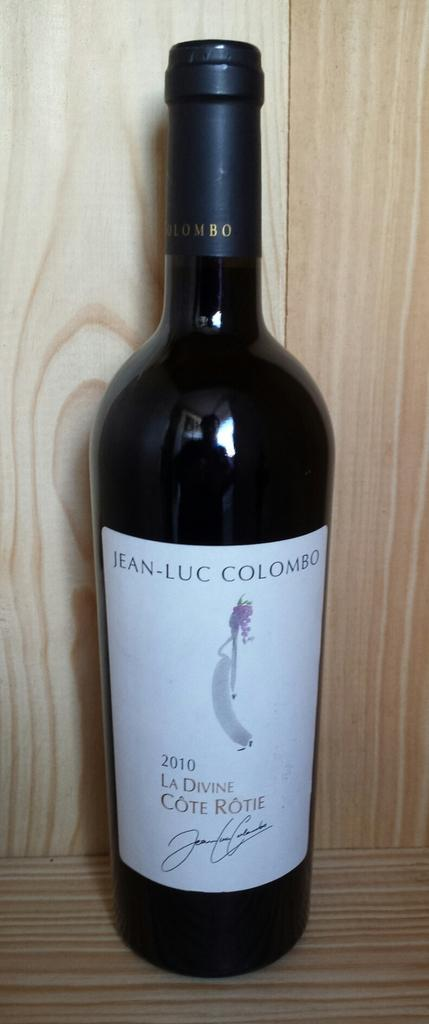Provide a one-sentence caption for the provided image. A 2010 bottle of La Divine Cote Rotie stands on a wood shelf. 